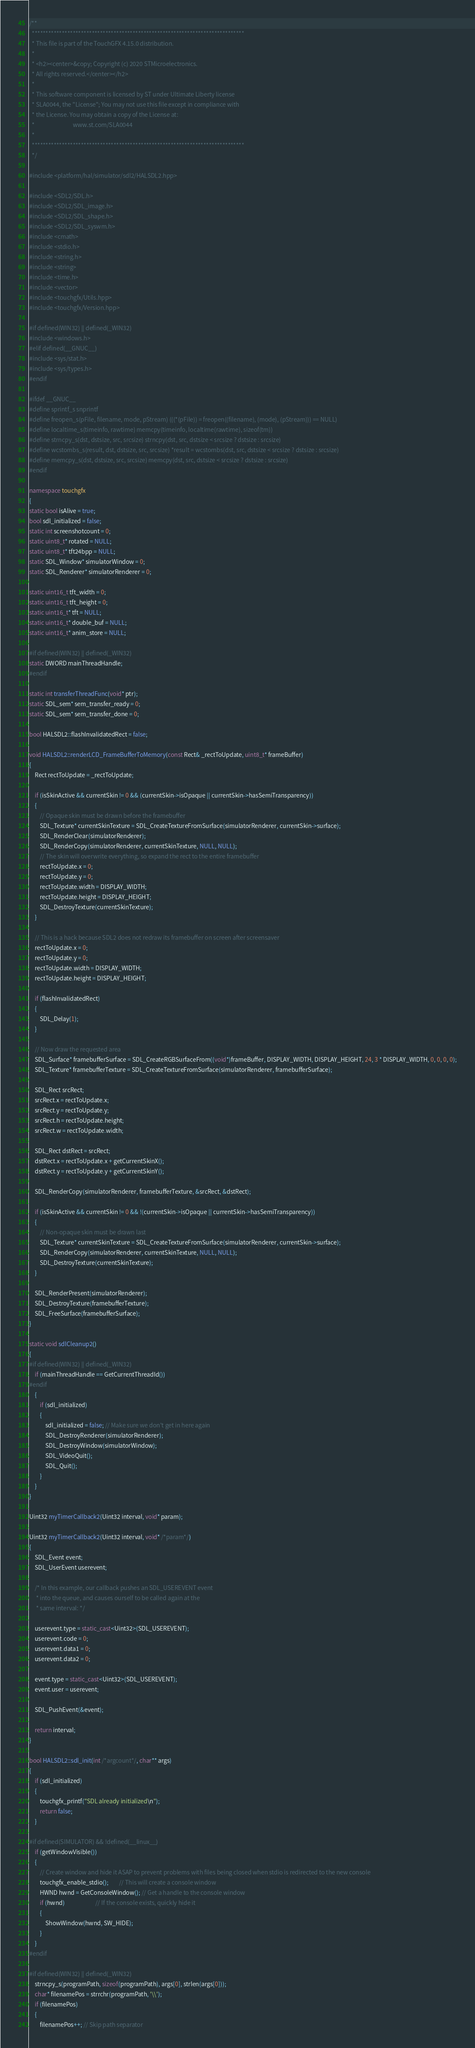<code> <loc_0><loc_0><loc_500><loc_500><_C++_>/**
  ******************************************************************************
  * This file is part of the TouchGFX 4.15.0 distribution.
  *
  * <h2><center>&copy; Copyright (c) 2020 STMicroelectronics.
  * All rights reserved.</center></h2>
  *
  * This software component is licensed by ST under Ultimate Liberty license
  * SLA0044, the "License"; You may not use this file except in compliance with
  * the License. You may obtain a copy of the License at:
  *                             www.st.com/SLA0044
  *
  ******************************************************************************
  */

#include <platform/hal/simulator/sdl2/HALSDL2.hpp>

#include <SDL2/SDL.h>
#include <SDL2/SDL_image.h>
#include <SDL2/SDL_shape.h>
#include <SDL2/SDL_syswm.h>
#include <cmath>
#include <stdio.h>
#include <string.h>
#include <string>
#include <time.h>
#include <vector>
#include <touchgfx/Utils.hpp>
#include <touchgfx/Version.hpp>

#if defined(WIN32) || defined(_WIN32)
#include <windows.h>
#elif defined(__GNUC__)
#include <sys/stat.h>
#include <sys/types.h>
#endif

#ifdef __GNUC__
#define sprintf_s snprintf
#define freopen_s(pFile, filename, mode, pStream) (((*(pFile)) = freopen((filename), (mode), (pStream))) == NULL)
#define localtime_s(timeinfo, rawtime) memcpy(timeinfo, localtime(rawtime), sizeof(tm))
#define strncpy_s(dst, dstsize, src, srcsize) strncpy(dst, src, dstsize < srcsize ? dstsize : srcsize)
#define wcstombs_s(result, dst, dstsize, src, srcsize) *result = wcstombs(dst, src, dstsize < srcsize ? dstsize : srcsize)
#define memcpy_s(dst, dstsize, src, srcsize) memcpy(dst, src, dstsize < srcsize ? dstsize : srcsize)
#endif

namespace touchgfx
{
static bool isAlive = true;
bool sdl_initialized = false;
static int screenshotcount = 0;
static uint8_t* rotated = NULL;
static uint8_t* tft24bpp = NULL;
static SDL_Window* simulatorWindow = 0;
static SDL_Renderer* simulatorRenderer = 0;

static uint16_t tft_width = 0;
static uint16_t tft_height = 0;
static uint16_t* tft = NULL;
static uint16_t* double_buf = NULL;
static uint16_t* anim_store = NULL;

#if defined(WIN32) || defined(_WIN32)
static DWORD mainThreadHandle;
#endif

static int transferThreadFunc(void* ptr);
static SDL_sem* sem_transfer_ready = 0;
static SDL_sem* sem_transfer_done = 0;

bool HALSDL2::flashInvalidatedRect = false;

void HALSDL2::renderLCD_FrameBufferToMemory(const Rect& _rectToUpdate, uint8_t* frameBuffer)
{
    Rect rectToUpdate = _rectToUpdate;

    if (isSkinActive && currentSkin != 0 && (currentSkin->isOpaque || currentSkin->hasSemiTransparency))
    {
        // Opaque skin must be drawn before the framebuffer
        SDL_Texture* currentSkinTexture = SDL_CreateTextureFromSurface(simulatorRenderer, currentSkin->surface);
        SDL_RenderClear(simulatorRenderer);
        SDL_RenderCopy(simulatorRenderer, currentSkinTexture, NULL, NULL);
        // The skin will overwrite everything, so expand the rect to the entire framebuffer
        rectToUpdate.x = 0;
        rectToUpdate.y = 0;
        rectToUpdate.width = DISPLAY_WIDTH;
        rectToUpdate.height = DISPLAY_HEIGHT;
        SDL_DestroyTexture(currentSkinTexture);
    }

    // This is a hack because SDL2 does not redraw its framebuffer on screen after screensaver
    rectToUpdate.x = 0;
    rectToUpdate.y = 0;
    rectToUpdate.width = DISPLAY_WIDTH;
    rectToUpdate.height = DISPLAY_HEIGHT;

    if (flashInvalidatedRect)
    {
        SDL_Delay(1);
    }

    // Now draw the requested area
    SDL_Surface* framebufferSurface = SDL_CreateRGBSurfaceFrom((void*)frameBuffer, DISPLAY_WIDTH, DISPLAY_HEIGHT, 24, 3 * DISPLAY_WIDTH, 0, 0, 0, 0);
    SDL_Texture* framebufferTexture = SDL_CreateTextureFromSurface(simulatorRenderer, framebufferSurface);

    SDL_Rect srcRect;
    srcRect.x = rectToUpdate.x;
    srcRect.y = rectToUpdate.y;
    srcRect.h = rectToUpdate.height;
    srcRect.w = rectToUpdate.width;

    SDL_Rect dstRect = srcRect;
    dstRect.x = rectToUpdate.x + getCurrentSkinX();
    dstRect.y = rectToUpdate.y + getCurrentSkinY();

    SDL_RenderCopy(simulatorRenderer, framebufferTexture, &srcRect, &dstRect);

    if (isSkinActive && currentSkin != 0 && !(currentSkin->isOpaque || currentSkin->hasSemiTransparency))
    {
        // Non-opaque skin must be drawn last
        SDL_Texture* currentSkinTexture = SDL_CreateTextureFromSurface(simulatorRenderer, currentSkin->surface);
        SDL_RenderCopy(simulatorRenderer, currentSkinTexture, NULL, NULL);
        SDL_DestroyTexture(currentSkinTexture);
    }

    SDL_RenderPresent(simulatorRenderer);
    SDL_DestroyTexture(framebufferTexture);
    SDL_FreeSurface(framebufferSurface);
}

static void sdlCleanup2()
{
#if defined(WIN32) || defined(_WIN32)
    if (mainThreadHandle == GetCurrentThreadId())
#endif
    {
        if (sdl_initialized)
        {
            sdl_initialized = false; // Make sure we don't get in here again
            SDL_DestroyRenderer(simulatorRenderer);
            SDL_DestroyWindow(simulatorWindow);
            SDL_VideoQuit();
            SDL_Quit();
        }
    }
}

Uint32 myTimerCallback2(Uint32 interval, void* param);

Uint32 myTimerCallback2(Uint32 interval, void* /*param*/)
{
    SDL_Event event;
    SDL_UserEvent userevent;

    /* In this example, our callback pushes an SDL_USEREVENT event
     * into the queue, and causes ourself to be called again at the
     * same interval: */

    userevent.type = static_cast<Uint32>(SDL_USEREVENT);
    userevent.code = 0;
    userevent.data1 = 0;
    userevent.data2 = 0;

    event.type = static_cast<Uint32>(SDL_USEREVENT);
    event.user = userevent;

    SDL_PushEvent(&event);

    return interval;
}

bool HALSDL2::sdl_init(int /*argcount*/, char** args)
{
    if (sdl_initialized)
    {
        touchgfx_printf("SDL already initialized\n");
        return false;
    }

#if defined(SIMULATOR) && !defined(__linux__)
    if (getWindowVisible())
    {
        // Create window and hide it ASAP to prevent problems with files being closed when stdio is redirected to the new console
        touchgfx_enable_stdio();        // This will create a console window
        HWND hwnd = GetConsoleWindow(); // Get a handle to the console window
        if (hwnd)                       // If the console exists, quickly hide it
        {
            ShowWindow(hwnd, SW_HIDE);
        }
    }
#endif

#if defined(WIN32) || defined(_WIN32)
    strncpy_s(programPath, sizeof(programPath), args[0], strlen(args[0]));
    char* filenamePos = strrchr(programPath, '\\');
    if (filenamePos)
    {
        filenamePos++; // Skip path separator</code> 